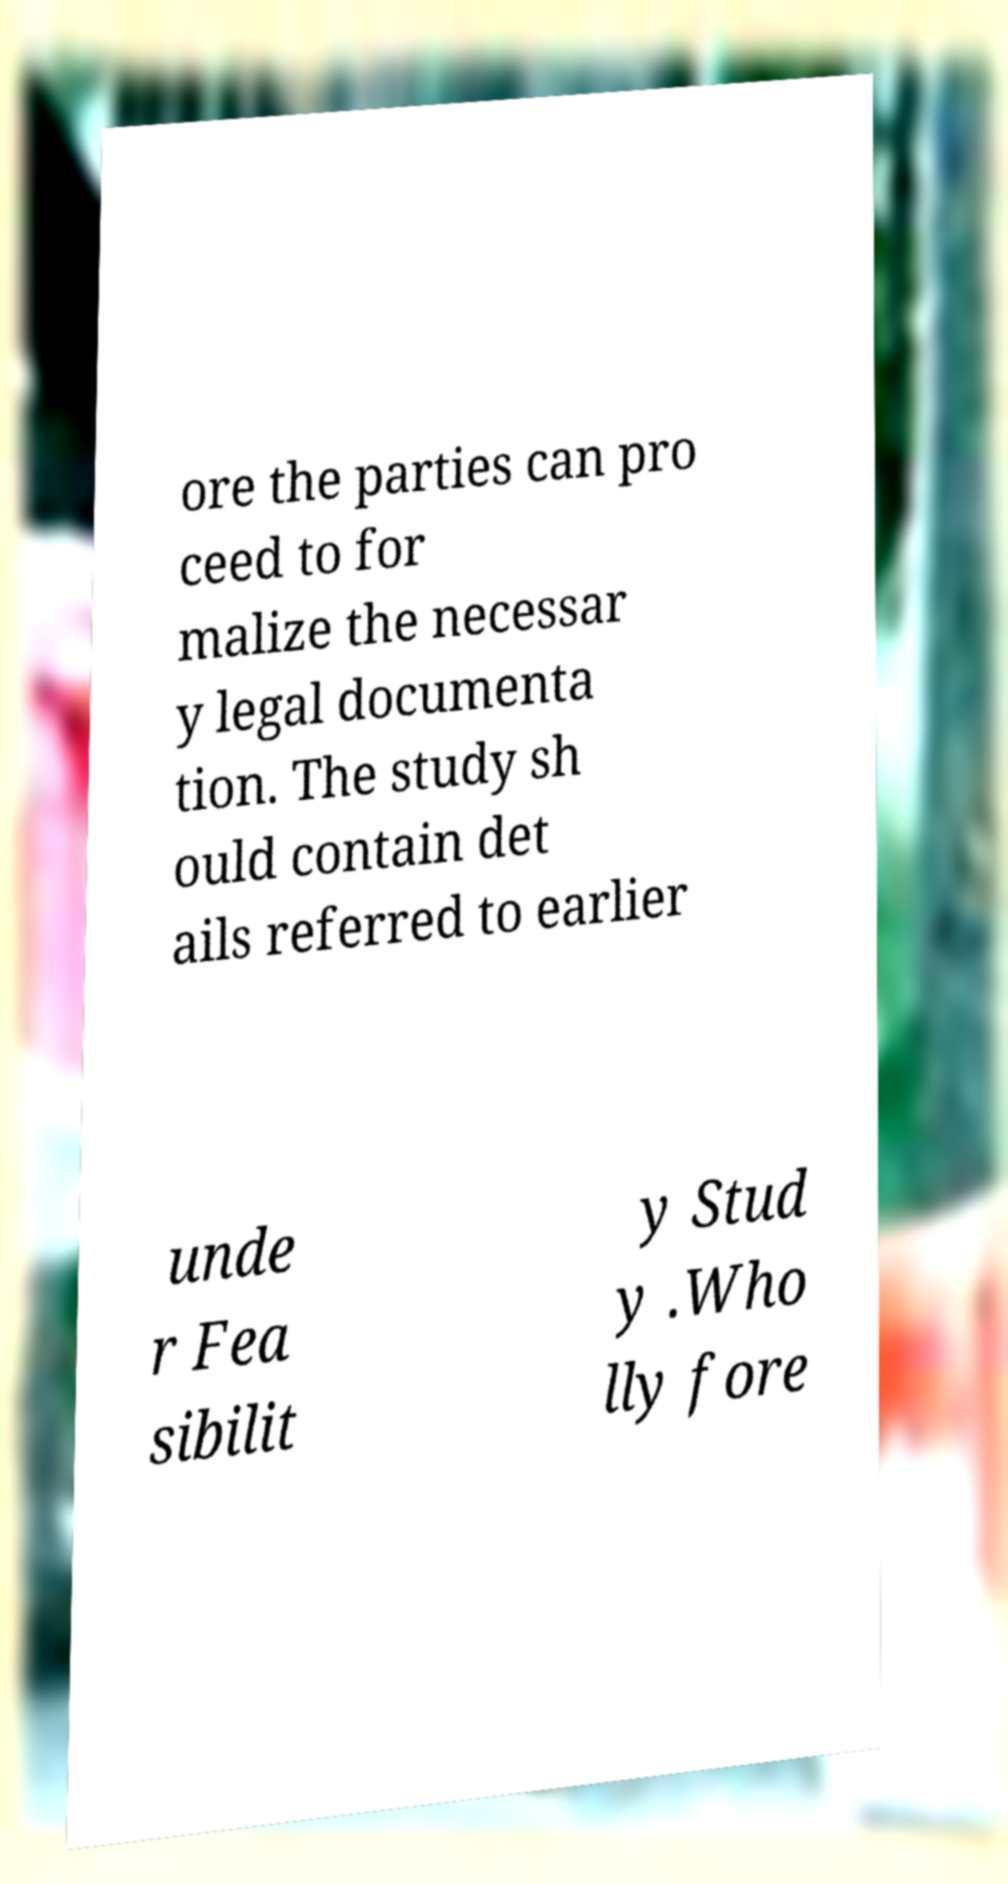Can you read and provide the text displayed in the image?This photo seems to have some interesting text. Can you extract and type it out for me? ore the parties can pro ceed to for malize the necessar y legal documenta tion. The study sh ould contain det ails referred to earlier unde r Fea sibilit y Stud y .Who lly fore 